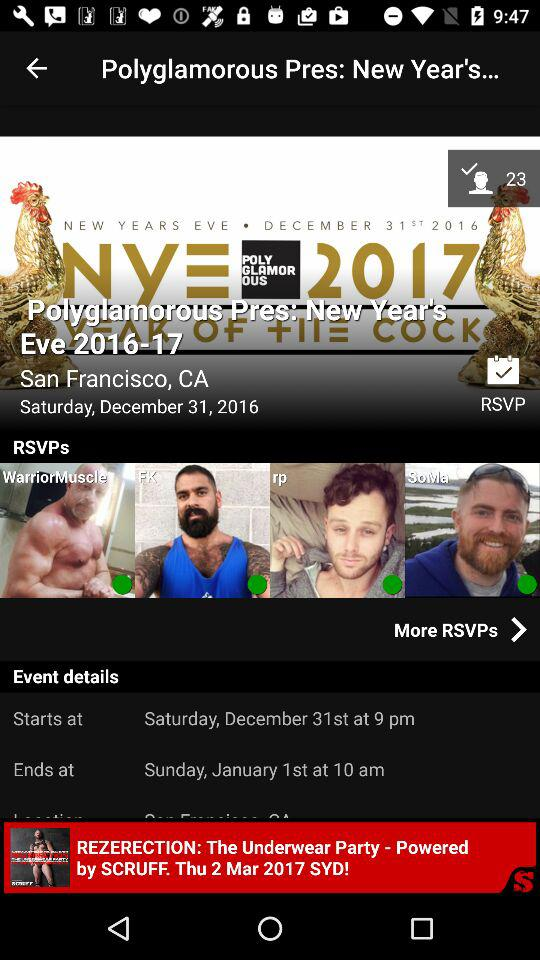Where will the "Polyglamorous Pres: New Year's Eve" be held? The "Polyglamorous Pres: New Year's Eve" will be held in San Francisco, CA. 